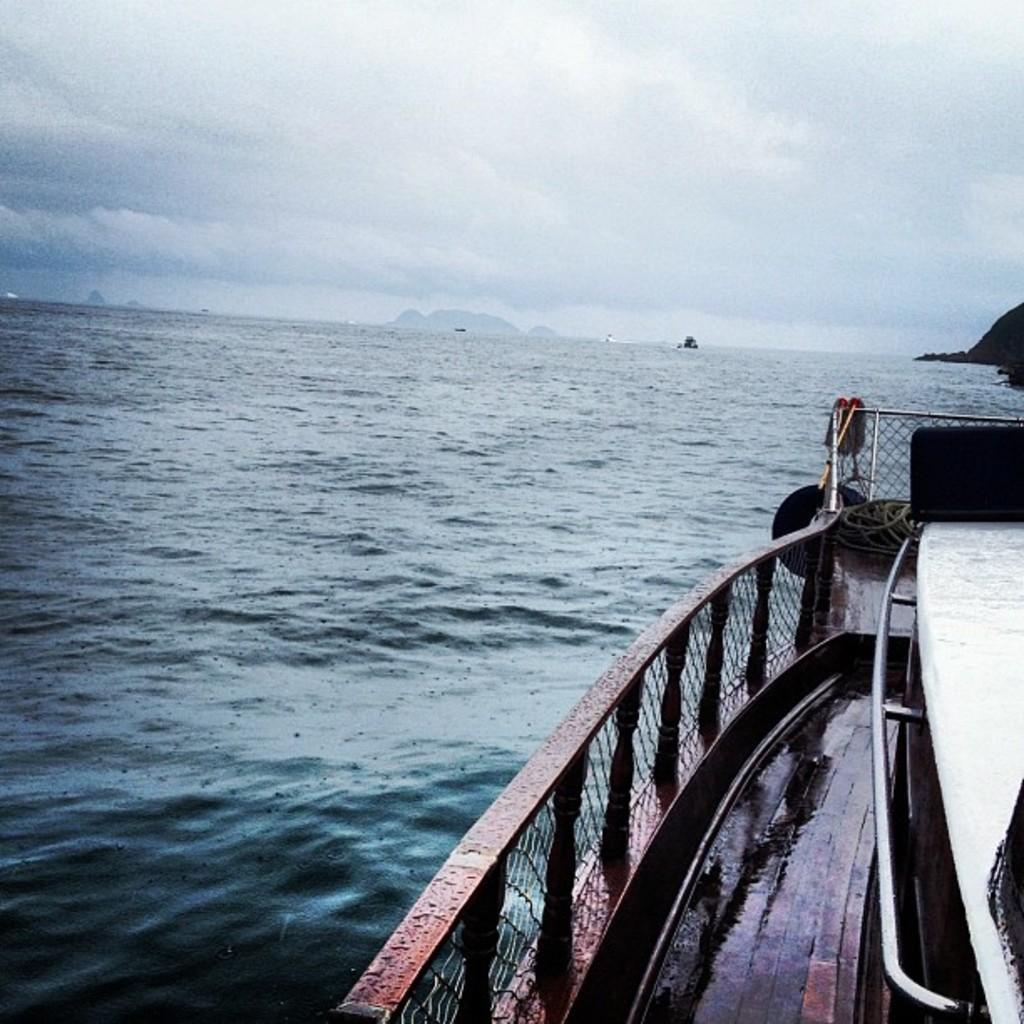Could you give a brief overview of what you see in this image? In the background we can see the sky and hills are visible. In this picture we can see the water and on the right side of the picture we can see the partial part of a ship. We can see the rod. 